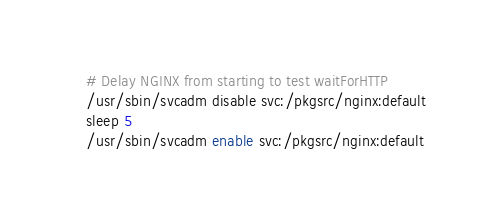<code> <loc_0><loc_0><loc_500><loc_500><_Bash_># Delay NGINX from starting to test waitForHTTP
/usr/sbin/svcadm disable svc:/pkgsrc/nginx:default
sleep 5
/usr/sbin/svcadm enable svc:/pkgsrc/nginx:default</code> 